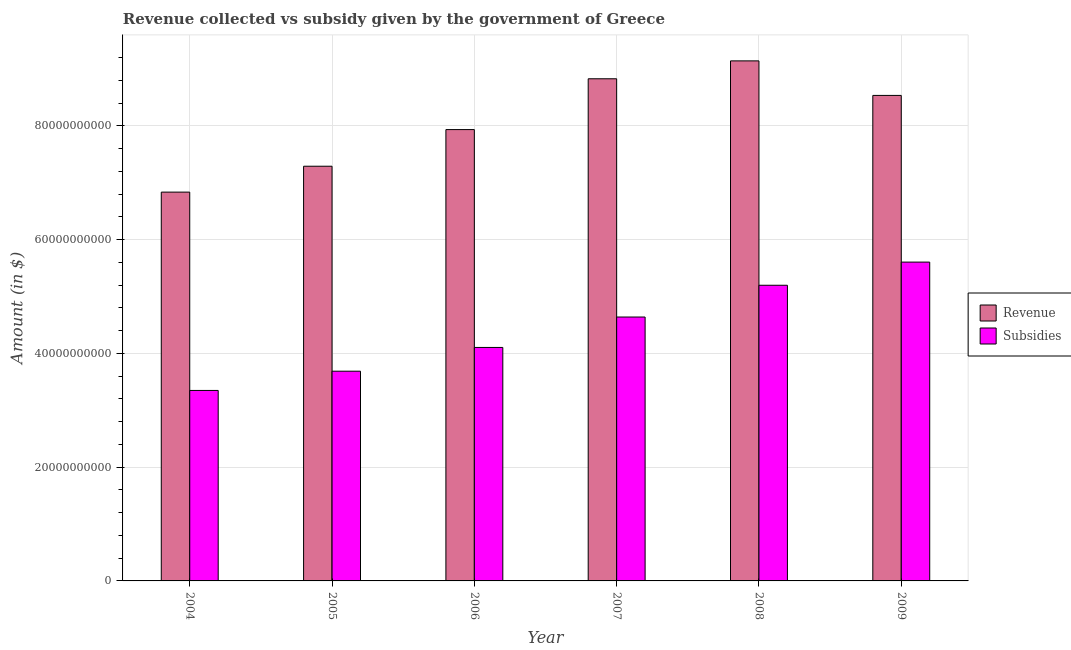How many different coloured bars are there?
Your answer should be very brief. 2. Are the number of bars per tick equal to the number of legend labels?
Give a very brief answer. Yes. How many bars are there on the 4th tick from the left?
Provide a succinct answer. 2. In how many cases, is the number of bars for a given year not equal to the number of legend labels?
Your answer should be compact. 0. What is the amount of subsidies given in 2005?
Offer a terse response. 3.69e+1. Across all years, what is the maximum amount of subsidies given?
Your answer should be compact. 5.60e+1. Across all years, what is the minimum amount of revenue collected?
Your answer should be very brief. 6.83e+1. In which year was the amount of revenue collected minimum?
Make the answer very short. 2004. What is the total amount of subsidies given in the graph?
Provide a short and direct response. 2.66e+11. What is the difference between the amount of revenue collected in 2004 and that in 2008?
Your answer should be very brief. -2.31e+1. What is the difference between the amount of subsidies given in 2008 and the amount of revenue collected in 2007?
Provide a short and direct response. 5.58e+09. What is the average amount of revenue collected per year?
Provide a short and direct response. 8.09e+1. In how many years, is the amount of revenue collected greater than 68000000000 $?
Your answer should be very brief. 6. What is the ratio of the amount of subsidies given in 2004 to that in 2007?
Ensure brevity in your answer.  0.72. Is the difference between the amount of subsidies given in 2004 and 2009 greater than the difference between the amount of revenue collected in 2004 and 2009?
Provide a short and direct response. No. What is the difference between the highest and the second highest amount of subsidies given?
Keep it short and to the point. 4.07e+09. What is the difference between the highest and the lowest amount of subsidies given?
Give a very brief answer. 2.26e+1. In how many years, is the amount of revenue collected greater than the average amount of revenue collected taken over all years?
Your answer should be compact. 3. Is the sum of the amount of revenue collected in 2004 and 2005 greater than the maximum amount of subsidies given across all years?
Make the answer very short. Yes. What does the 1st bar from the left in 2007 represents?
Offer a very short reply. Revenue. What does the 2nd bar from the right in 2007 represents?
Make the answer very short. Revenue. Are the values on the major ticks of Y-axis written in scientific E-notation?
Keep it short and to the point. No. Does the graph contain any zero values?
Your response must be concise. No. Does the graph contain grids?
Offer a terse response. Yes. Where does the legend appear in the graph?
Offer a terse response. Center right. How many legend labels are there?
Your answer should be very brief. 2. What is the title of the graph?
Your response must be concise. Revenue collected vs subsidy given by the government of Greece. What is the label or title of the X-axis?
Your answer should be compact. Year. What is the label or title of the Y-axis?
Give a very brief answer. Amount (in $). What is the Amount (in $) of Revenue in 2004?
Ensure brevity in your answer.  6.83e+1. What is the Amount (in $) in Subsidies in 2004?
Your answer should be very brief. 3.35e+1. What is the Amount (in $) of Revenue in 2005?
Your answer should be compact. 7.29e+1. What is the Amount (in $) of Subsidies in 2005?
Your answer should be compact. 3.69e+1. What is the Amount (in $) in Revenue in 2006?
Give a very brief answer. 7.93e+1. What is the Amount (in $) in Subsidies in 2006?
Offer a very short reply. 4.10e+1. What is the Amount (in $) of Revenue in 2007?
Your answer should be very brief. 8.83e+1. What is the Amount (in $) of Subsidies in 2007?
Ensure brevity in your answer.  4.64e+1. What is the Amount (in $) in Revenue in 2008?
Offer a terse response. 9.14e+1. What is the Amount (in $) of Subsidies in 2008?
Provide a succinct answer. 5.20e+1. What is the Amount (in $) of Revenue in 2009?
Your response must be concise. 8.53e+1. What is the Amount (in $) in Subsidies in 2009?
Provide a succinct answer. 5.60e+1. Across all years, what is the maximum Amount (in $) in Revenue?
Keep it short and to the point. 9.14e+1. Across all years, what is the maximum Amount (in $) of Subsidies?
Your answer should be compact. 5.60e+1. Across all years, what is the minimum Amount (in $) in Revenue?
Keep it short and to the point. 6.83e+1. Across all years, what is the minimum Amount (in $) of Subsidies?
Your response must be concise. 3.35e+1. What is the total Amount (in $) in Revenue in the graph?
Make the answer very short. 4.86e+11. What is the total Amount (in $) in Subsidies in the graph?
Keep it short and to the point. 2.66e+11. What is the difference between the Amount (in $) of Revenue in 2004 and that in 2005?
Ensure brevity in your answer.  -4.55e+09. What is the difference between the Amount (in $) in Subsidies in 2004 and that in 2005?
Keep it short and to the point. -3.39e+09. What is the difference between the Amount (in $) in Revenue in 2004 and that in 2006?
Provide a short and direct response. -1.10e+1. What is the difference between the Amount (in $) of Subsidies in 2004 and that in 2006?
Provide a succinct answer. -7.56e+09. What is the difference between the Amount (in $) in Revenue in 2004 and that in 2007?
Give a very brief answer. -1.99e+1. What is the difference between the Amount (in $) in Subsidies in 2004 and that in 2007?
Your response must be concise. -1.29e+1. What is the difference between the Amount (in $) in Revenue in 2004 and that in 2008?
Provide a succinct answer. -2.31e+1. What is the difference between the Amount (in $) in Subsidies in 2004 and that in 2008?
Give a very brief answer. -1.85e+1. What is the difference between the Amount (in $) in Revenue in 2004 and that in 2009?
Your answer should be very brief. -1.70e+1. What is the difference between the Amount (in $) in Subsidies in 2004 and that in 2009?
Give a very brief answer. -2.26e+1. What is the difference between the Amount (in $) of Revenue in 2005 and that in 2006?
Your response must be concise. -6.44e+09. What is the difference between the Amount (in $) of Subsidies in 2005 and that in 2006?
Offer a terse response. -4.17e+09. What is the difference between the Amount (in $) in Revenue in 2005 and that in 2007?
Make the answer very short. -1.54e+1. What is the difference between the Amount (in $) in Subsidies in 2005 and that in 2007?
Offer a terse response. -9.52e+09. What is the difference between the Amount (in $) in Revenue in 2005 and that in 2008?
Offer a very short reply. -1.85e+1. What is the difference between the Amount (in $) in Subsidies in 2005 and that in 2008?
Give a very brief answer. -1.51e+1. What is the difference between the Amount (in $) of Revenue in 2005 and that in 2009?
Give a very brief answer. -1.24e+1. What is the difference between the Amount (in $) of Subsidies in 2005 and that in 2009?
Your answer should be compact. -1.92e+1. What is the difference between the Amount (in $) in Revenue in 2006 and that in 2007?
Offer a terse response. -8.93e+09. What is the difference between the Amount (in $) of Subsidies in 2006 and that in 2007?
Keep it short and to the point. -5.35e+09. What is the difference between the Amount (in $) of Revenue in 2006 and that in 2008?
Offer a very short reply. -1.21e+1. What is the difference between the Amount (in $) of Subsidies in 2006 and that in 2008?
Provide a succinct answer. -1.09e+1. What is the difference between the Amount (in $) in Revenue in 2006 and that in 2009?
Offer a very short reply. -6.01e+09. What is the difference between the Amount (in $) in Subsidies in 2006 and that in 2009?
Provide a succinct answer. -1.50e+1. What is the difference between the Amount (in $) of Revenue in 2007 and that in 2008?
Provide a succinct answer. -3.15e+09. What is the difference between the Amount (in $) of Subsidies in 2007 and that in 2008?
Your answer should be compact. -5.58e+09. What is the difference between the Amount (in $) in Revenue in 2007 and that in 2009?
Keep it short and to the point. 2.93e+09. What is the difference between the Amount (in $) of Subsidies in 2007 and that in 2009?
Offer a very short reply. -9.66e+09. What is the difference between the Amount (in $) in Revenue in 2008 and that in 2009?
Offer a very short reply. 6.07e+09. What is the difference between the Amount (in $) of Subsidies in 2008 and that in 2009?
Your answer should be compact. -4.07e+09. What is the difference between the Amount (in $) of Revenue in 2004 and the Amount (in $) of Subsidies in 2005?
Provide a succinct answer. 3.15e+1. What is the difference between the Amount (in $) of Revenue in 2004 and the Amount (in $) of Subsidies in 2006?
Offer a very short reply. 2.73e+1. What is the difference between the Amount (in $) of Revenue in 2004 and the Amount (in $) of Subsidies in 2007?
Make the answer very short. 2.20e+1. What is the difference between the Amount (in $) in Revenue in 2004 and the Amount (in $) in Subsidies in 2008?
Offer a very short reply. 1.64e+1. What is the difference between the Amount (in $) in Revenue in 2004 and the Amount (in $) in Subsidies in 2009?
Provide a succinct answer. 1.23e+1. What is the difference between the Amount (in $) of Revenue in 2005 and the Amount (in $) of Subsidies in 2006?
Provide a short and direct response. 3.19e+1. What is the difference between the Amount (in $) of Revenue in 2005 and the Amount (in $) of Subsidies in 2007?
Offer a very short reply. 2.65e+1. What is the difference between the Amount (in $) in Revenue in 2005 and the Amount (in $) in Subsidies in 2008?
Provide a short and direct response. 2.09e+1. What is the difference between the Amount (in $) of Revenue in 2005 and the Amount (in $) of Subsidies in 2009?
Offer a very short reply. 1.69e+1. What is the difference between the Amount (in $) in Revenue in 2006 and the Amount (in $) in Subsidies in 2007?
Offer a very short reply. 3.29e+1. What is the difference between the Amount (in $) in Revenue in 2006 and the Amount (in $) in Subsidies in 2008?
Provide a succinct answer. 2.74e+1. What is the difference between the Amount (in $) of Revenue in 2006 and the Amount (in $) of Subsidies in 2009?
Ensure brevity in your answer.  2.33e+1. What is the difference between the Amount (in $) in Revenue in 2007 and the Amount (in $) in Subsidies in 2008?
Your response must be concise. 3.63e+1. What is the difference between the Amount (in $) of Revenue in 2007 and the Amount (in $) of Subsidies in 2009?
Make the answer very short. 3.22e+1. What is the difference between the Amount (in $) in Revenue in 2008 and the Amount (in $) in Subsidies in 2009?
Your answer should be very brief. 3.54e+1. What is the average Amount (in $) in Revenue per year?
Your answer should be very brief. 8.09e+1. What is the average Amount (in $) in Subsidies per year?
Offer a terse response. 4.43e+1. In the year 2004, what is the difference between the Amount (in $) of Revenue and Amount (in $) of Subsidies?
Provide a succinct answer. 3.49e+1. In the year 2005, what is the difference between the Amount (in $) in Revenue and Amount (in $) in Subsidies?
Provide a short and direct response. 3.60e+1. In the year 2006, what is the difference between the Amount (in $) of Revenue and Amount (in $) of Subsidies?
Provide a succinct answer. 3.83e+1. In the year 2007, what is the difference between the Amount (in $) of Revenue and Amount (in $) of Subsidies?
Keep it short and to the point. 4.19e+1. In the year 2008, what is the difference between the Amount (in $) of Revenue and Amount (in $) of Subsidies?
Provide a succinct answer. 3.94e+1. In the year 2009, what is the difference between the Amount (in $) in Revenue and Amount (in $) in Subsidies?
Your response must be concise. 2.93e+1. What is the ratio of the Amount (in $) of Revenue in 2004 to that in 2005?
Keep it short and to the point. 0.94. What is the ratio of the Amount (in $) of Subsidies in 2004 to that in 2005?
Provide a short and direct response. 0.91. What is the ratio of the Amount (in $) in Revenue in 2004 to that in 2006?
Your answer should be compact. 0.86. What is the ratio of the Amount (in $) of Subsidies in 2004 to that in 2006?
Provide a short and direct response. 0.82. What is the ratio of the Amount (in $) of Revenue in 2004 to that in 2007?
Your answer should be very brief. 0.77. What is the ratio of the Amount (in $) in Subsidies in 2004 to that in 2007?
Give a very brief answer. 0.72. What is the ratio of the Amount (in $) of Revenue in 2004 to that in 2008?
Your answer should be compact. 0.75. What is the ratio of the Amount (in $) in Subsidies in 2004 to that in 2008?
Ensure brevity in your answer.  0.64. What is the ratio of the Amount (in $) in Revenue in 2004 to that in 2009?
Offer a terse response. 0.8. What is the ratio of the Amount (in $) of Subsidies in 2004 to that in 2009?
Ensure brevity in your answer.  0.6. What is the ratio of the Amount (in $) in Revenue in 2005 to that in 2006?
Your response must be concise. 0.92. What is the ratio of the Amount (in $) in Subsidies in 2005 to that in 2006?
Ensure brevity in your answer.  0.9. What is the ratio of the Amount (in $) in Revenue in 2005 to that in 2007?
Provide a short and direct response. 0.83. What is the ratio of the Amount (in $) in Subsidies in 2005 to that in 2007?
Keep it short and to the point. 0.79. What is the ratio of the Amount (in $) in Revenue in 2005 to that in 2008?
Make the answer very short. 0.8. What is the ratio of the Amount (in $) of Subsidies in 2005 to that in 2008?
Provide a short and direct response. 0.71. What is the ratio of the Amount (in $) of Revenue in 2005 to that in 2009?
Your answer should be very brief. 0.85. What is the ratio of the Amount (in $) in Subsidies in 2005 to that in 2009?
Your answer should be very brief. 0.66. What is the ratio of the Amount (in $) of Revenue in 2006 to that in 2007?
Ensure brevity in your answer.  0.9. What is the ratio of the Amount (in $) of Subsidies in 2006 to that in 2007?
Your answer should be very brief. 0.88. What is the ratio of the Amount (in $) of Revenue in 2006 to that in 2008?
Provide a succinct answer. 0.87. What is the ratio of the Amount (in $) in Subsidies in 2006 to that in 2008?
Your response must be concise. 0.79. What is the ratio of the Amount (in $) of Revenue in 2006 to that in 2009?
Give a very brief answer. 0.93. What is the ratio of the Amount (in $) of Subsidies in 2006 to that in 2009?
Your answer should be compact. 0.73. What is the ratio of the Amount (in $) of Revenue in 2007 to that in 2008?
Your answer should be very brief. 0.97. What is the ratio of the Amount (in $) of Subsidies in 2007 to that in 2008?
Offer a very short reply. 0.89. What is the ratio of the Amount (in $) of Revenue in 2007 to that in 2009?
Provide a short and direct response. 1.03. What is the ratio of the Amount (in $) in Subsidies in 2007 to that in 2009?
Provide a short and direct response. 0.83. What is the ratio of the Amount (in $) of Revenue in 2008 to that in 2009?
Ensure brevity in your answer.  1.07. What is the ratio of the Amount (in $) of Subsidies in 2008 to that in 2009?
Offer a terse response. 0.93. What is the difference between the highest and the second highest Amount (in $) in Revenue?
Your answer should be compact. 3.15e+09. What is the difference between the highest and the second highest Amount (in $) in Subsidies?
Keep it short and to the point. 4.07e+09. What is the difference between the highest and the lowest Amount (in $) in Revenue?
Your answer should be compact. 2.31e+1. What is the difference between the highest and the lowest Amount (in $) in Subsidies?
Make the answer very short. 2.26e+1. 